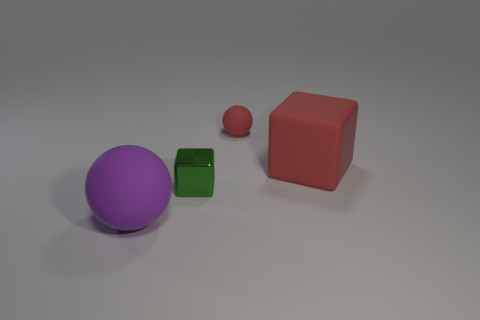What is the size of the matte block that is the same color as the tiny sphere?
Provide a succinct answer. Large. There is a big object that is the same color as the tiny rubber sphere; what shape is it?
Your answer should be very brief. Cube. Are there an equal number of matte spheres that are to the right of the tiny red rubber sphere and cubes?
Keep it short and to the point. No. Does the small object in front of the red rubber sphere have the same material as the tiny thing right of the small metallic cube?
Keep it short and to the point. No. Are there any other things that have the same material as the big red cube?
Make the answer very short. Yes. Does the tiny thing in front of the matte cube have the same shape as the big object that is to the left of the tiny rubber sphere?
Your answer should be very brief. No. Is the number of tiny things that are to the right of the small red object less than the number of tiny purple objects?
Your response must be concise. No. What number of other large matte cubes have the same color as the big matte block?
Make the answer very short. 0. There is a red thing in front of the small rubber object; what is its size?
Offer a terse response. Large. What shape is the large purple matte object that is in front of the red rubber object behind the large rubber thing that is right of the large purple thing?
Provide a succinct answer. Sphere. 